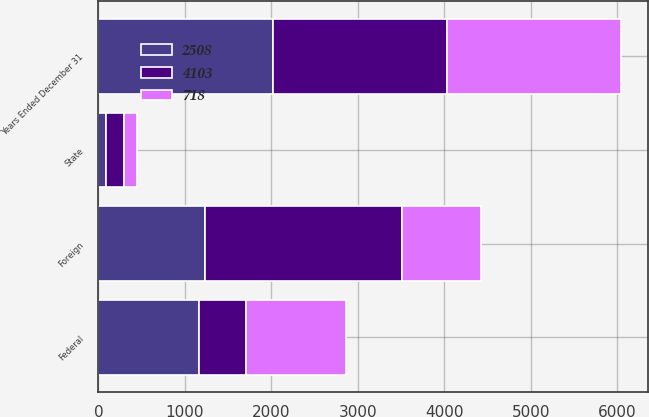<chart> <loc_0><loc_0><loc_500><loc_500><stacked_bar_chart><ecel><fcel>Years Ended December 31<fcel>Federal<fcel>Foreign<fcel>State<nl><fcel>4103<fcel>2018<fcel>536<fcel>2281<fcel>200<nl><fcel>2508<fcel>2017<fcel>1166<fcel>1229<fcel>90<nl><fcel>718<fcel>2016<fcel>1166<fcel>916<fcel>157<nl></chart> 